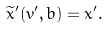<formula> <loc_0><loc_0><loc_500><loc_500>\widetilde { x } ^ { \prime } ( v ^ { \prime } , b ) = x ^ { \prime } .</formula> 